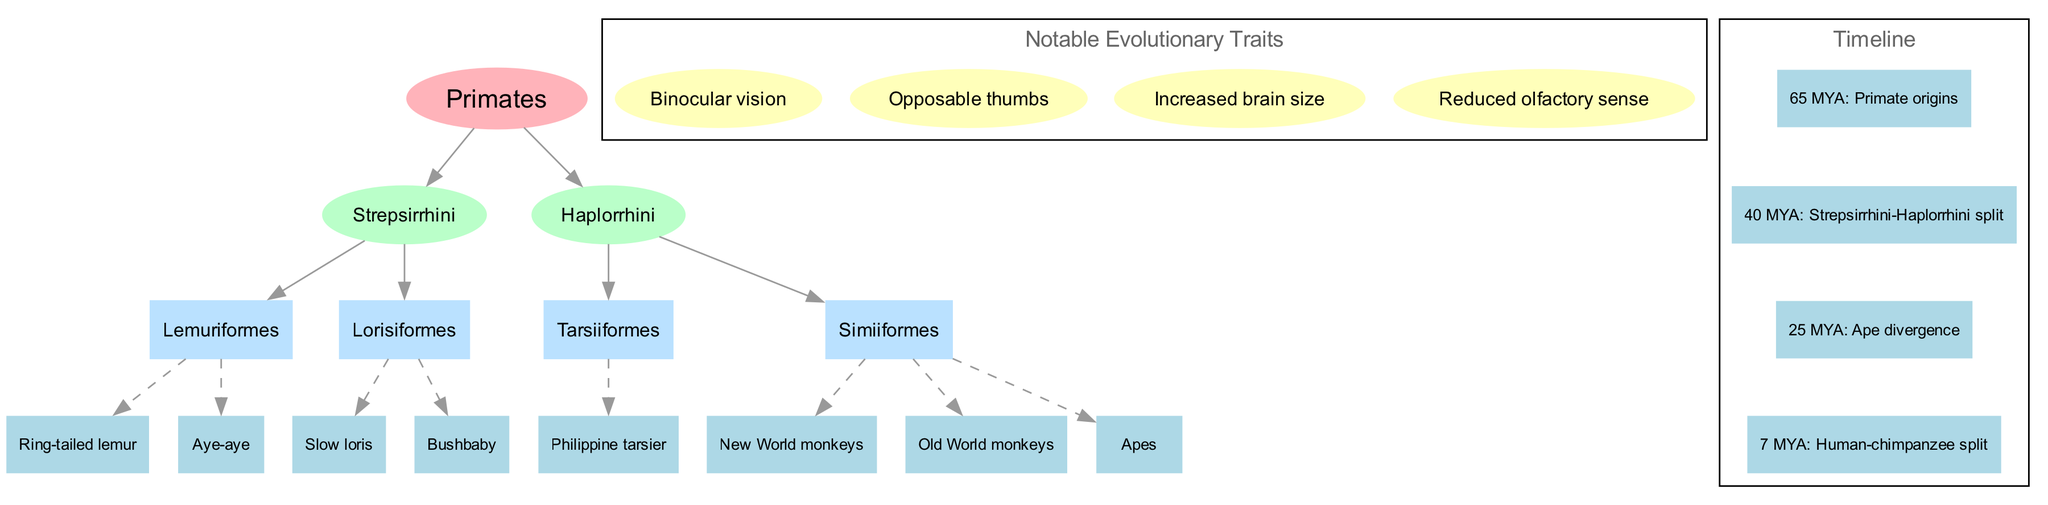What are the two main branches of primates? The diagram shows two main branches stemming from the root 'Primates,' which are 'Strepsirrhini' and 'Haplorrhini.'
Answer: Strepsirrhini, Haplorrhini Which major group includes the Aye-aye? The Aye-aye is listed as a species example under the sub-branch 'Lemuriformes,' which falls under the main branch 'Strepsirrhini.'
Answer: Lemuriformes How many species examples are listed for the Haplorrhini branch? The Haplorrhini branch contains one sub-branch, 'Tarsiiformes', which has one species example (Philippine tarsier), and 'Simiiformes', which has three examples (New World monkeys, Old World monkeys, Apes), totaling four species examples.
Answer: 4 What notable evolutionary trait is associated with increased brain size? The diagram lists 'Increased brain size' as one of the notable evolutionary traits. This indicates a key feature shared among primate species.
Answer: Increased brain size At what time period did the Strepsirrhini-Haplorrhini split occur? The diagram provides a timeline where the split between Strepsirrhini and Haplorrhini is marked at 40 million years ago (MYA).
Answer: 40 MYA What is the relationship between the 'Ring-tailed lemur' and 'Strepsirrhini'? The 'Ring-tailed lemur' is listed under the sub-branch 'Lemuriformes,' which is a part of the main branch 'Strepsirrhini,' indicating it belongs to this group directly.
Answer: Sub-branch relationship How many notable evolutionary traits are identified in the diagram? The diagram presents a total of four notable evolutionary traits, specifically 'Binocular vision,' 'Opposable thumbs,' 'Increased brain size,' and 'Reduced olfactory sense.'
Answer: 4 What is the last evolutionary split mentioned in the timeline? The timeline details the last evolutionary split as the 'Human-chimpanzee split,' which occurred 7 million years ago (MYA), marking a significant divergence in primate lineage.
Answer: Human-chimpanzee split Which sub-branch contains the species examples of both New World and Old World monkeys? The species examples of both New World monkeys and Old World monkeys fall under the sub-branch 'Simiiformes,' which is part of the Haplorrhini branch.
Answer: Simiiformes 